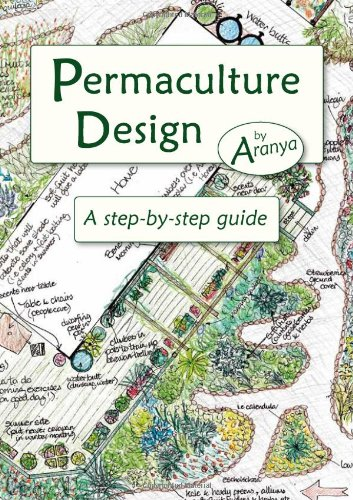What is the title of this book? The book, adorned with a detailed cover illustration, is titled 'Permaculture Design: A Step-by-Step Guide.' 